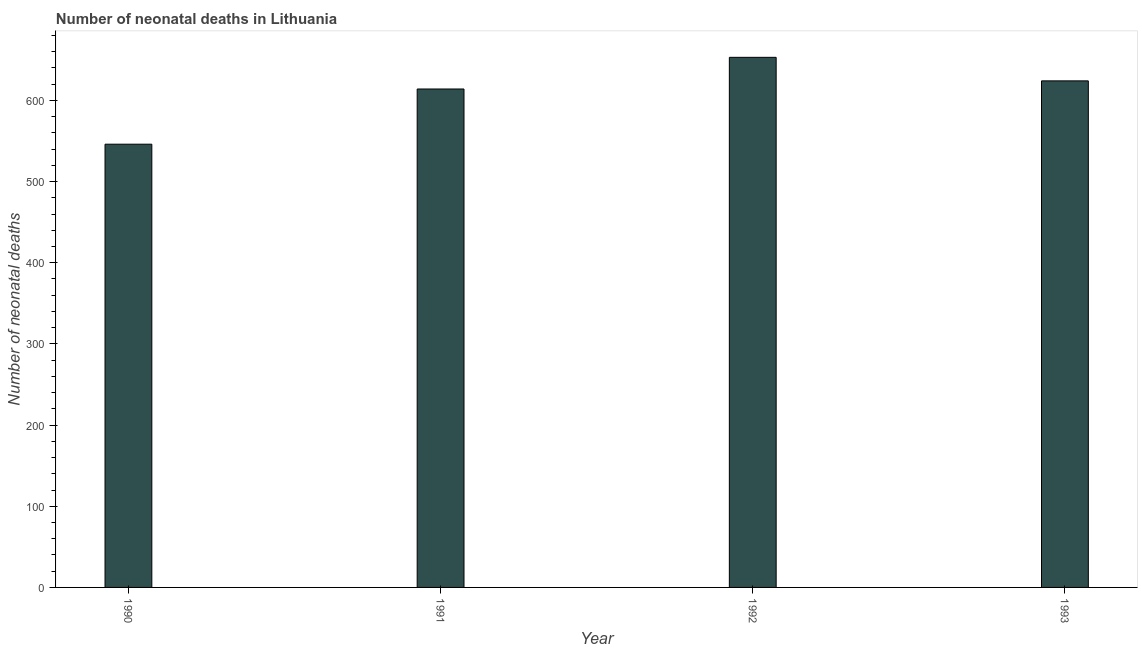Does the graph contain any zero values?
Make the answer very short. No. Does the graph contain grids?
Your answer should be very brief. No. What is the title of the graph?
Keep it short and to the point. Number of neonatal deaths in Lithuania. What is the label or title of the Y-axis?
Ensure brevity in your answer.  Number of neonatal deaths. What is the number of neonatal deaths in 1993?
Your response must be concise. 624. Across all years, what is the maximum number of neonatal deaths?
Ensure brevity in your answer.  653. Across all years, what is the minimum number of neonatal deaths?
Your answer should be compact. 546. What is the sum of the number of neonatal deaths?
Provide a succinct answer. 2437. What is the difference between the number of neonatal deaths in 1991 and 1992?
Provide a succinct answer. -39. What is the average number of neonatal deaths per year?
Provide a short and direct response. 609. What is the median number of neonatal deaths?
Offer a terse response. 619. Is the difference between the number of neonatal deaths in 1990 and 1991 greater than the difference between any two years?
Your answer should be compact. No. What is the difference between the highest and the second highest number of neonatal deaths?
Provide a succinct answer. 29. Is the sum of the number of neonatal deaths in 1992 and 1993 greater than the maximum number of neonatal deaths across all years?
Keep it short and to the point. Yes. What is the difference between the highest and the lowest number of neonatal deaths?
Offer a terse response. 107. How many bars are there?
Your answer should be very brief. 4. Are all the bars in the graph horizontal?
Keep it short and to the point. No. How many years are there in the graph?
Offer a terse response. 4. What is the difference between two consecutive major ticks on the Y-axis?
Ensure brevity in your answer.  100. What is the Number of neonatal deaths in 1990?
Ensure brevity in your answer.  546. What is the Number of neonatal deaths of 1991?
Ensure brevity in your answer.  614. What is the Number of neonatal deaths of 1992?
Keep it short and to the point. 653. What is the Number of neonatal deaths of 1993?
Offer a terse response. 624. What is the difference between the Number of neonatal deaths in 1990 and 1991?
Offer a very short reply. -68. What is the difference between the Number of neonatal deaths in 1990 and 1992?
Offer a terse response. -107. What is the difference between the Number of neonatal deaths in 1990 and 1993?
Offer a very short reply. -78. What is the difference between the Number of neonatal deaths in 1991 and 1992?
Your answer should be compact. -39. What is the difference between the Number of neonatal deaths in 1991 and 1993?
Offer a terse response. -10. What is the difference between the Number of neonatal deaths in 1992 and 1993?
Give a very brief answer. 29. What is the ratio of the Number of neonatal deaths in 1990 to that in 1991?
Give a very brief answer. 0.89. What is the ratio of the Number of neonatal deaths in 1990 to that in 1992?
Provide a succinct answer. 0.84. What is the ratio of the Number of neonatal deaths in 1990 to that in 1993?
Make the answer very short. 0.88. What is the ratio of the Number of neonatal deaths in 1991 to that in 1993?
Keep it short and to the point. 0.98. What is the ratio of the Number of neonatal deaths in 1992 to that in 1993?
Your answer should be compact. 1.05. 